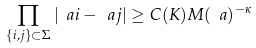<formula> <loc_0><loc_0><loc_500><loc_500>\prod _ { \{ i , j \} \subset \Sigma } | \ a i - \ a j | \geq C ( K ) M ( \ a ) ^ { - \kappa }</formula> 